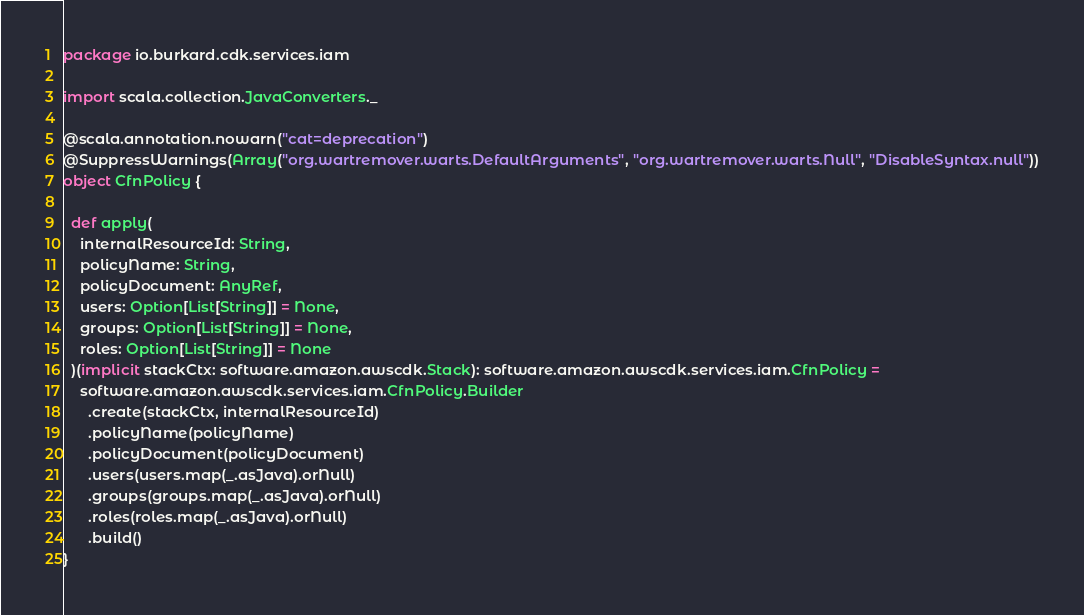Convert code to text. <code><loc_0><loc_0><loc_500><loc_500><_Scala_>package io.burkard.cdk.services.iam

import scala.collection.JavaConverters._

@scala.annotation.nowarn("cat=deprecation")
@SuppressWarnings(Array("org.wartremover.warts.DefaultArguments", "org.wartremover.warts.Null", "DisableSyntax.null"))
object CfnPolicy {

  def apply(
    internalResourceId: String,
    policyName: String,
    policyDocument: AnyRef,
    users: Option[List[String]] = None,
    groups: Option[List[String]] = None,
    roles: Option[List[String]] = None
  )(implicit stackCtx: software.amazon.awscdk.Stack): software.amazon.awscdk.services.iam.CfnPolicy =
    software.amazon.awscdk.services.iam.CfnPolicy.Builder
      .create(stackCtx, internalResourceId)
      .policyName(policyName)
      .policyDocument(policyDocument)
      .users(users.map(_.asJava).orNull)
      .groups(groups.map(_.asJava).orNull)
      .roles(roles.map(_.asJava).orNull)
      .build()
}
</code> 